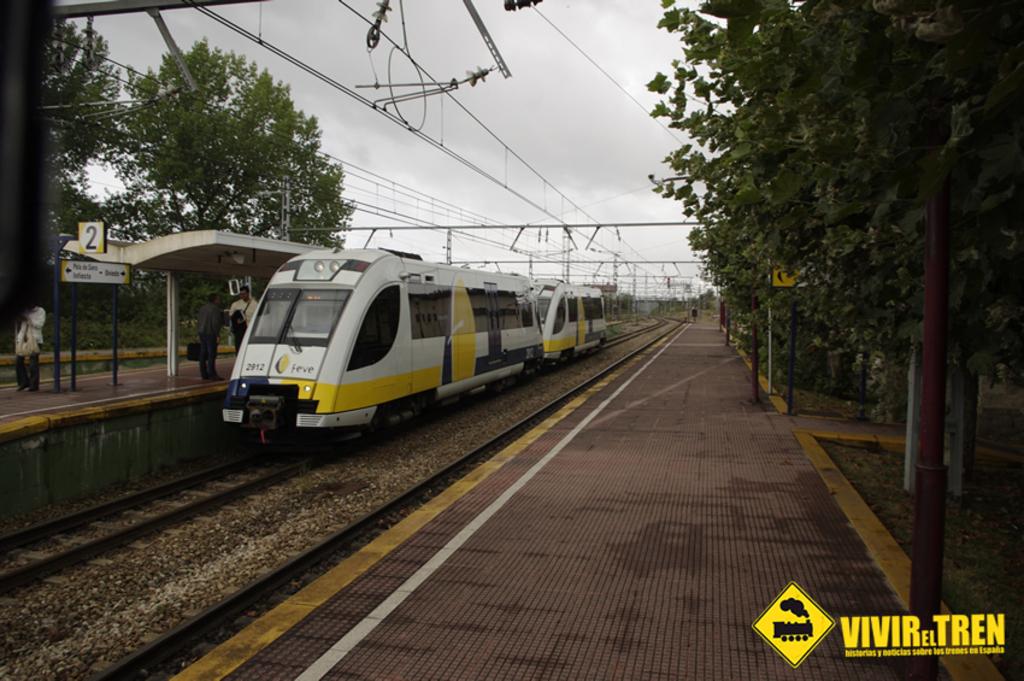What is in big yellow letters in the bottom right corner?
Offer a very short reply. Vivir el tren. 